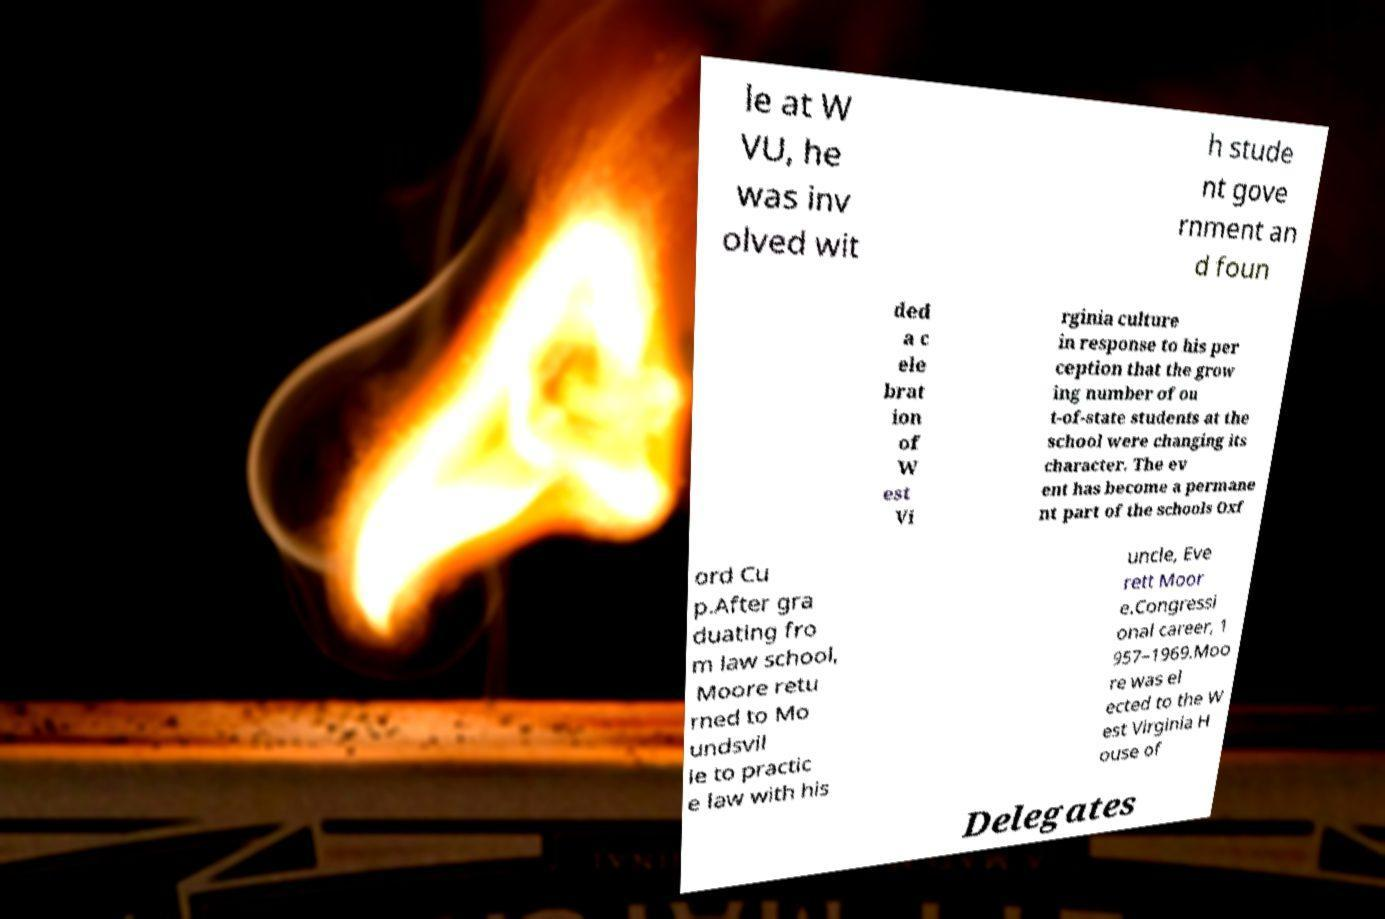Can you accurately transcribe the text from the provided image for me? le at W VU, he was inv olved wit h stude nt gove rnment an d foun ded a c ele brat ion of W est Vi rginia culture in response to his per ception that the grow ing number of ou t-of-state students at the school were changing its character. The ev ent has become a permane nt part of the schools Oxf ord Cu p.After gra duating fro m law school, Moore retu rned to Mo undsvil le to practic e law with his uncle, Eve rett Moor e.Congressi onal career, 1 957–1969.Moo re was el ected to the W est Virginia H ouse of Delegates 